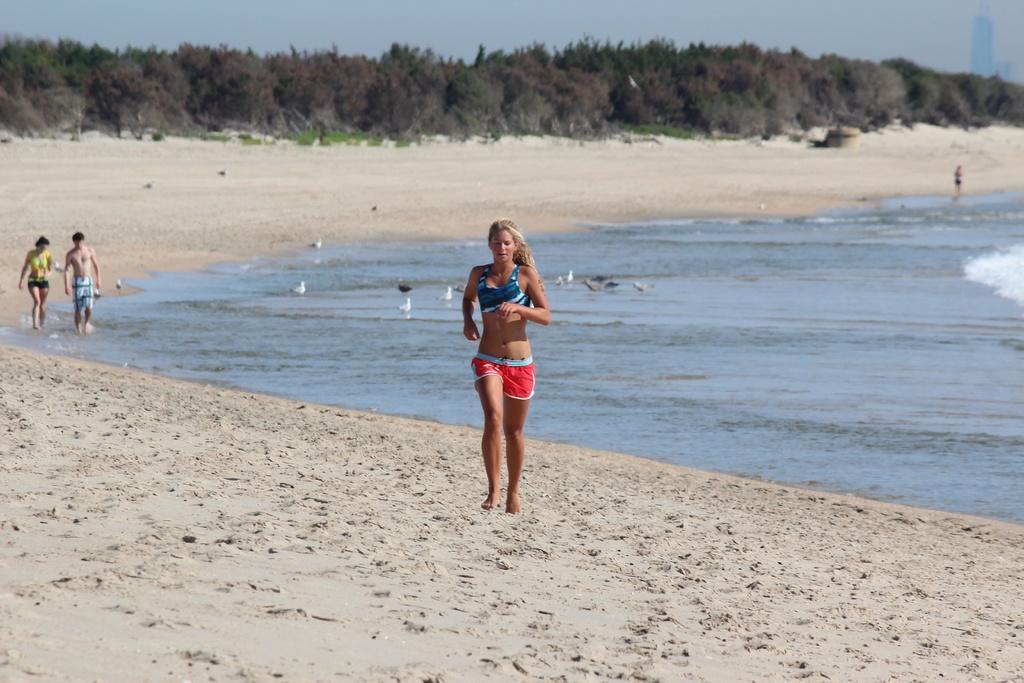Please provide a concise description of this image. In the center of the image a lady is running. In the background of the image we can see some persons, birds, water, trees are there. At the top of the image we can buildings, sky are there. At the bottom of the image the soil is there. 